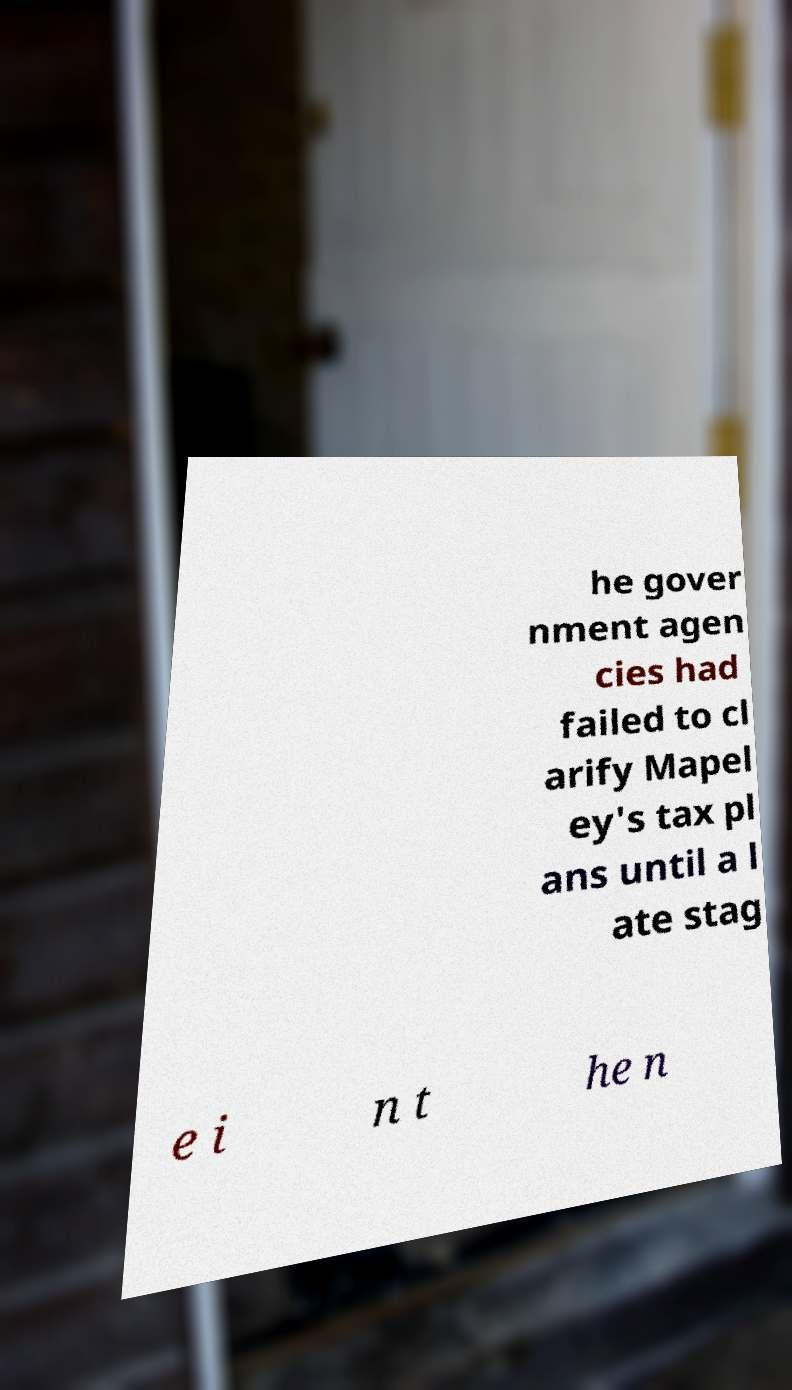Can you accurately transcribe the text from the provided image for me? he gover nment agen cies had failed to cl arify Mapel ey's tax pl ans until a l ate stag e i n t he n 